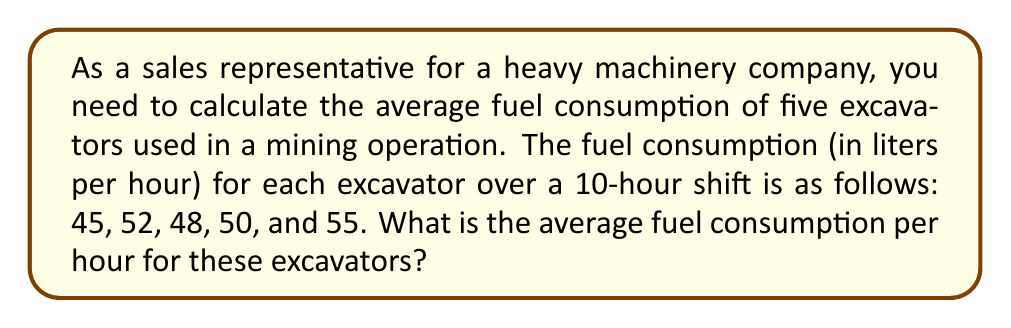Show me your answer to this math problem. To find the average fuel consumption, we need to:
1. Sum up the fuel consumption of all excavators
2. Divide the sum by the number of excavators

Let's follow these steps:

1. Sum of fuel consumption:
   $$45 + 52 + 48 + 50 + 55 = 250$$ liters per hour

2. Number of excavators: 5

3. Calculate the average:
   $$\text{Average} = \frac{\text{Sum of values}}{\text{Number of values}}$$
   $$\text{Average} = \frac{250}{5} = 50$$ liters per hour

Therefore, the average fuel consumption per hour for these excavators is 50 liters.
Answer: The average fuel consumption is 50 liters per hour. 